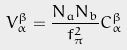<formula> <loc_0><loc_0><loc_500><loc_500>V _ { \alpha } ^ { \beta } = \frac { N _ { a } N _ { b } } { f _ { \pi } ^ { 2 } } C _ { \alpha } ^ { \beta }</formula> 